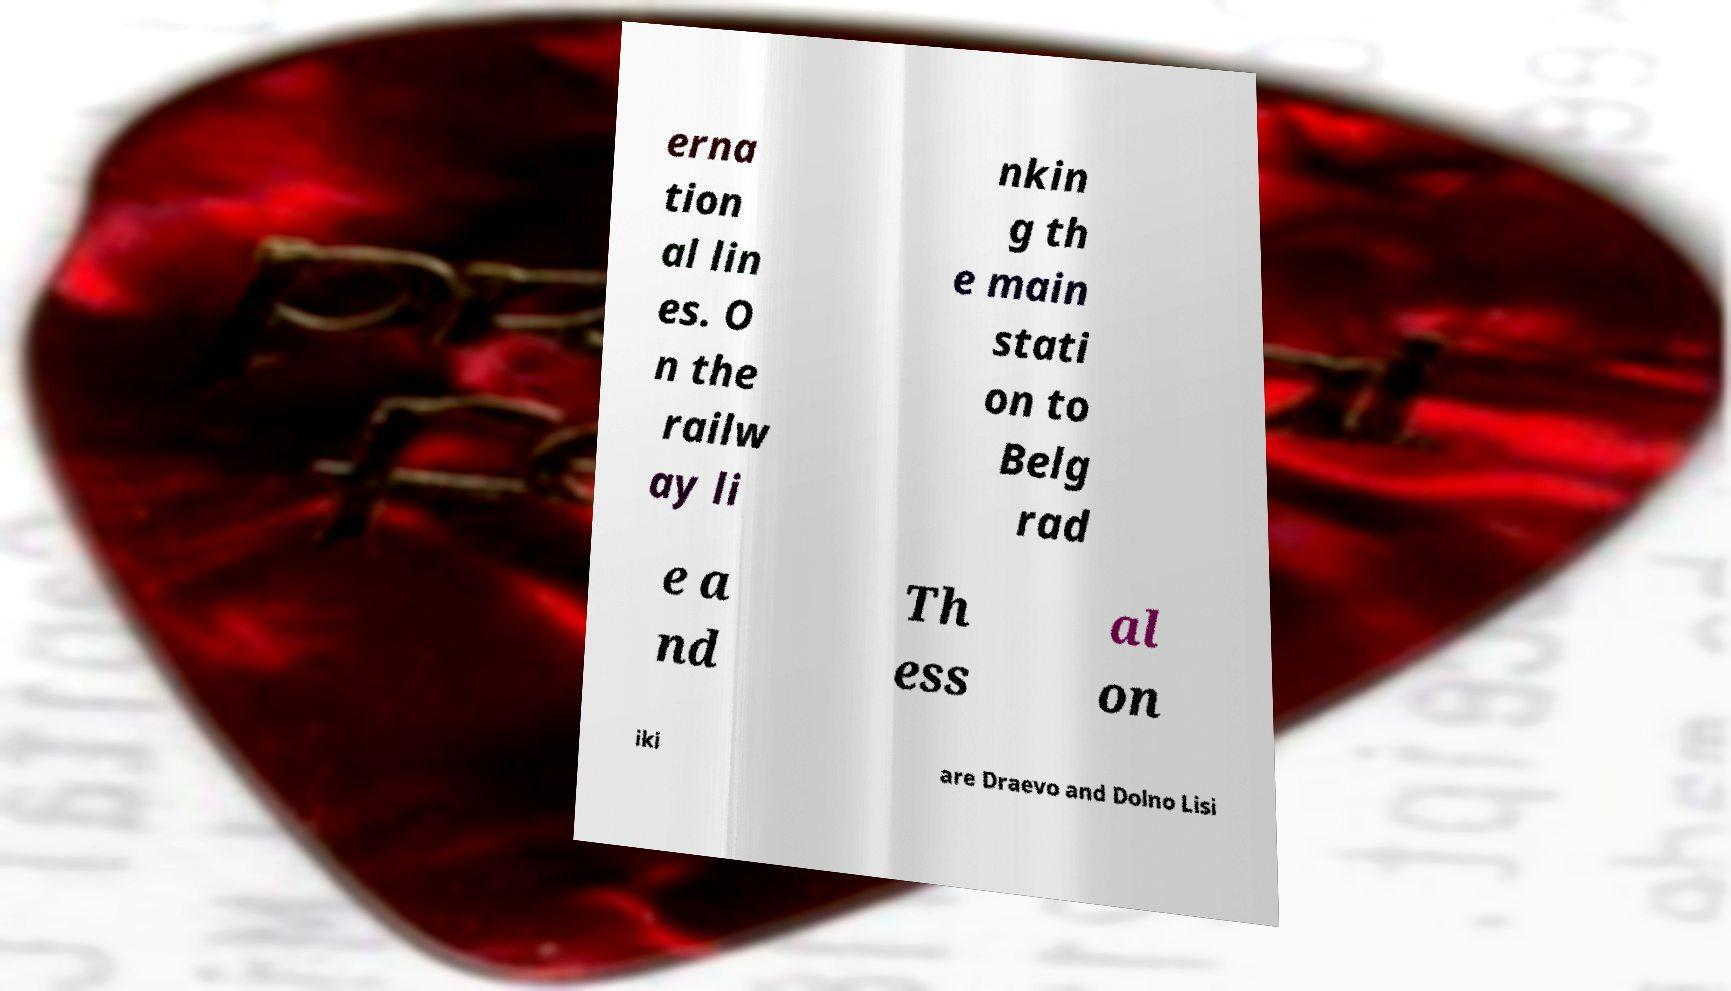Could you extract and type out the text from this image? erna tion al lin es. O n the railw ay li nkin g th e main stati on to Belg rad e a nd Th ess al on iki are Draevo and Dolno Lisi 